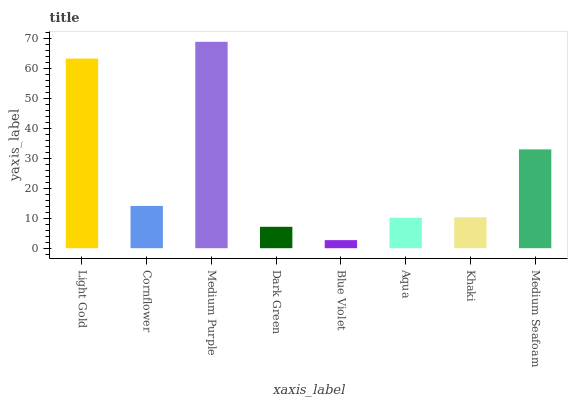Is Blue Violet the minimum?
Answer yes or no. Yes. Is Medium Purple the maximum?
Answer yes or no. Yes. Is Cornflower the minimum?
Answer yes or no. No. Is Cornflower the maximum?
Answer yes or no. No. Is Light Gold greater than Cornflower?
Answer yes or no. Yes. Is Cornflower less than Light Gold?
Answer yes or no. Yes. Is Cornflower greater than Light Gold?
Answer yes or no. No. Is Light Gold less than Cornflower?
Answer yes or no. No. Is Cornflower the high median?
Answer yes or no. Yes. Is Khaki the low median?
Answer yes or no. Yes. Is Blue Violet the high median?
Answer yes or no. No. Is Aqua the low median?
Answer yes or no. No. 